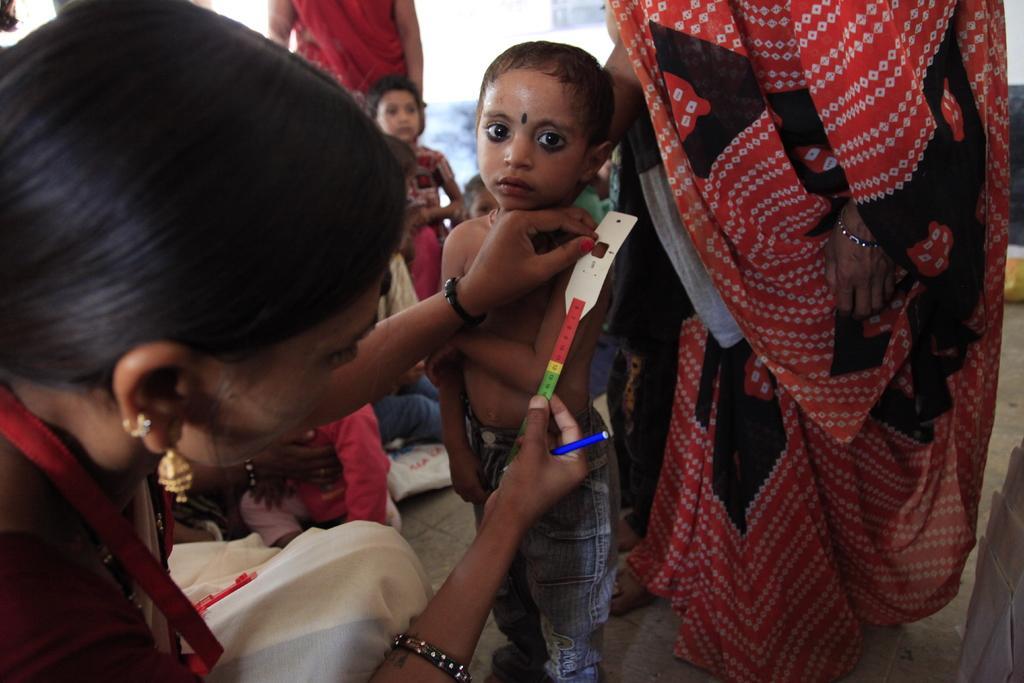Can you describe this image briefly? In this image, we can see people and one of them is wearing an id card and holding a scale and a pen. At the bottom, there is a floor. 